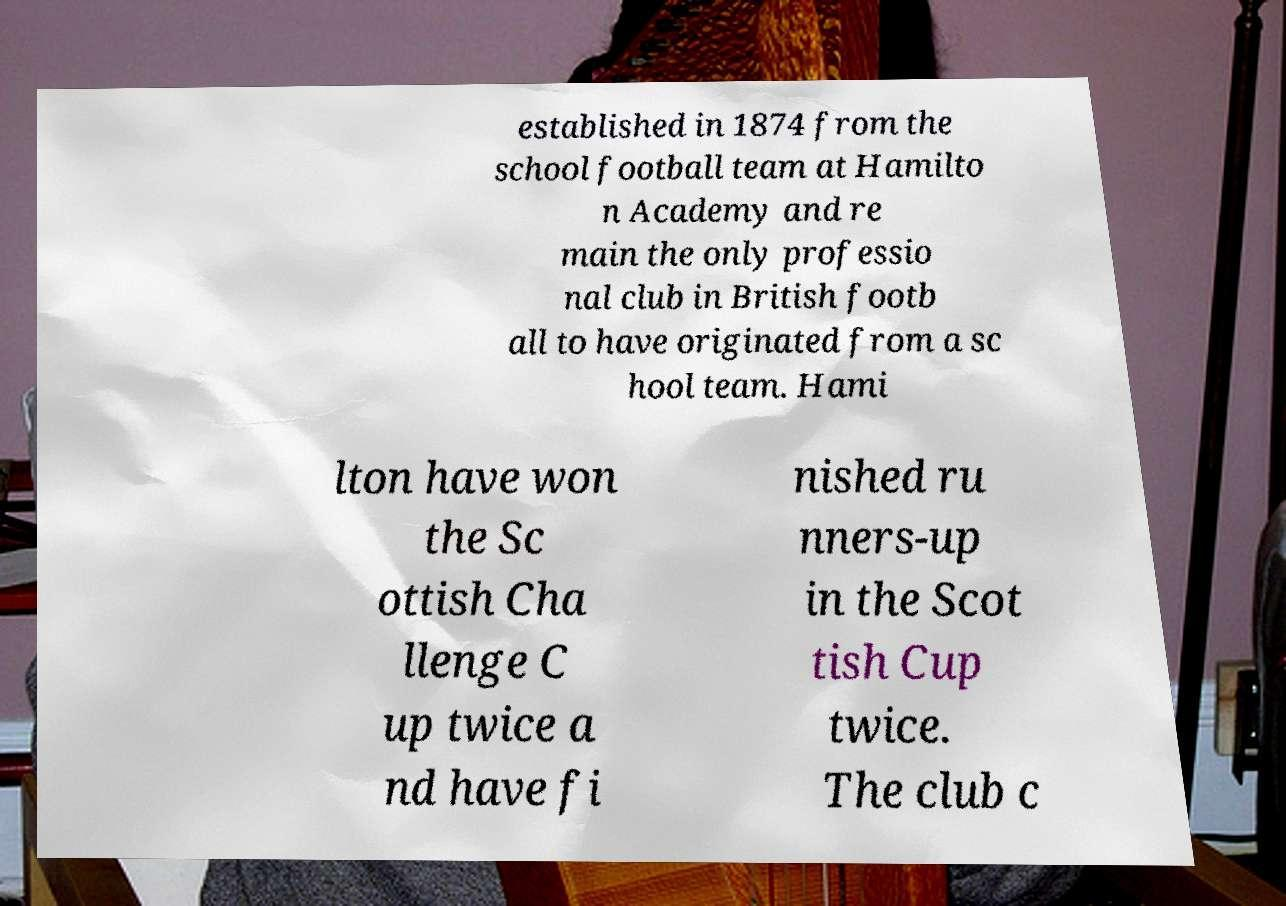I need the written content from this picture converted into text. Can you do that? established in 1874 from the school football team at Hamilto n Academy and re main the only professio nal club in British footb all to have originated from a sc hool team. Hami lton have won the Sc ottish Cha llenge C up twice a nd have fi nished ru nners-up in the Scot tish Cup twice. The club c 